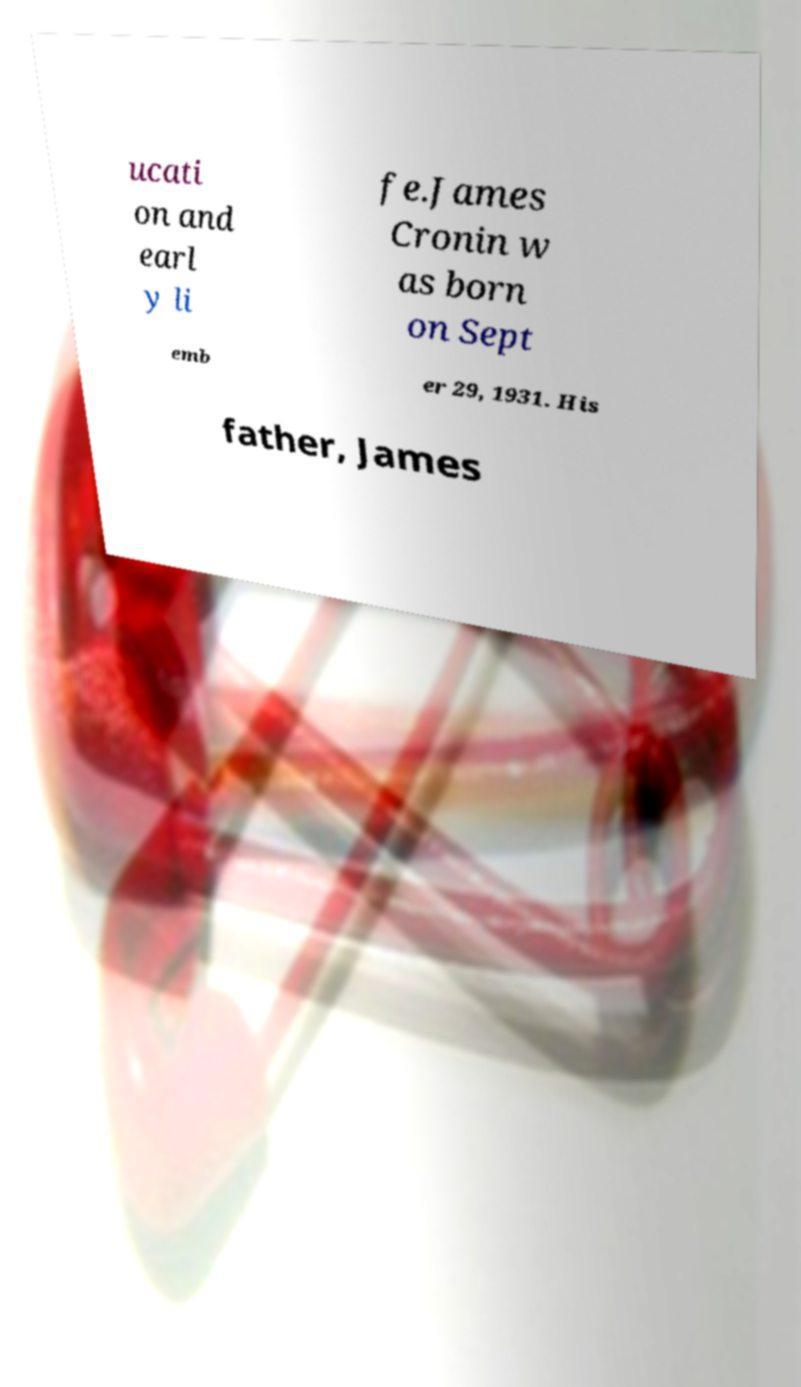Could you assist in decoding the text presented in this image and type it out clearly? ucati on and earl y li fe.James Cronin w as born on Sept emb er 29, 1931. His father, James 